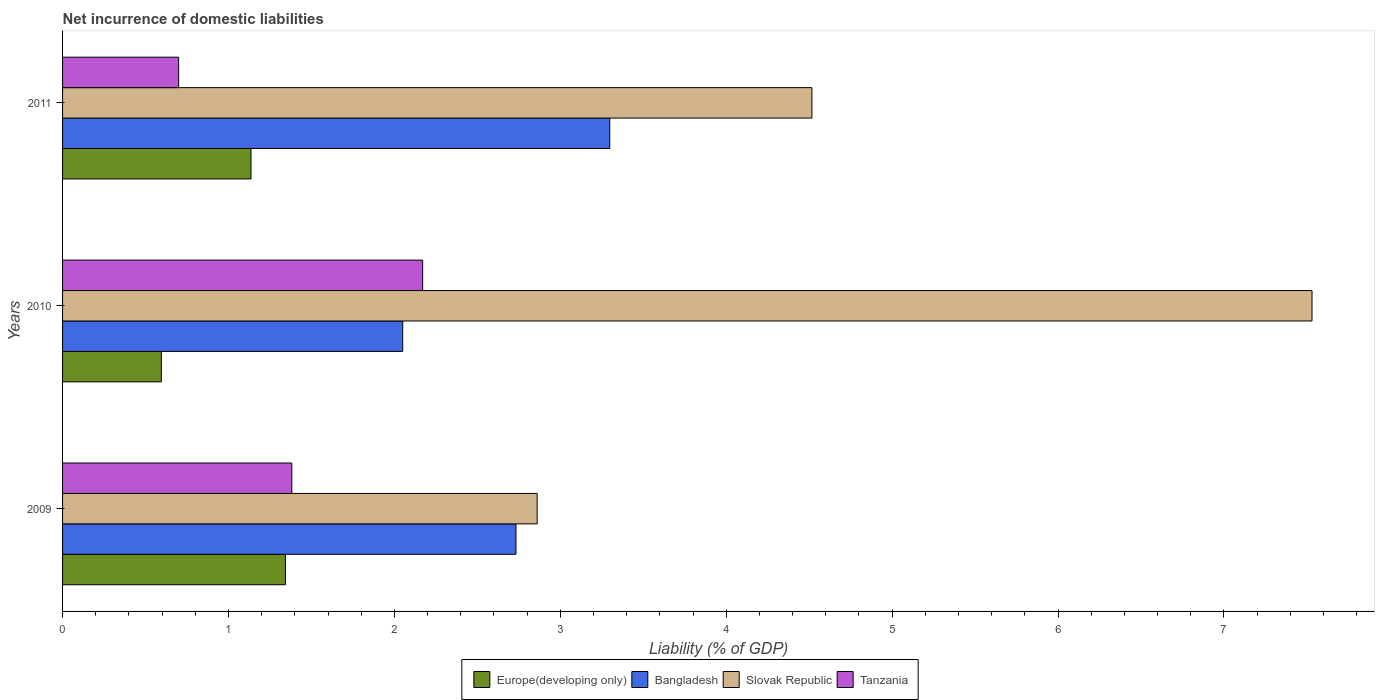Are the number of bars per tick equal to the number of legend labels?
Your answer should be compact. Yes. How many bars are there on the 2nd tick from the top?
Offer a very short reply. 4. In how many cases, is the number of bars for a given year not equal to the number of legend labels?
Offer a terse response. 0. What is the net incurrence of domestic liabilities in Europe(developing only) in 2010?
Provide a short and direct response. 0.6. Across all years, what is the maximum net incurrence of domestic liabilities in Slovak Republic?
Offer a terse response. 7.53. Across all years, what is the minimum net incurrence of domestic liabilities in Bangladesh?
Provide a short and direct response. 2.05. In which year was the net incurrence of domestic liabilities in Tanzania minimum?
Your answer should be compact. 2011. What is the total net incurrence of domestic liabilities in Slovak Republic in the graph?
Give a very brief answer. 14.91. What is the difference between the net incurrence of domestic liabilities in Europe(developing only) in 2009 and that in 2011?
Offer a terse response. 0.21. What is the difference between the net incurrence of domestic liabilities in Bangladesh in 2010 and the net incurrence of domestic liabilities in Tanzania in 2009?
Offer a very short reply. 0.67. What is the average net incurrence of domestic liabilities in Slovak Republic per year?
Make the answer very short. 4.97. In the year 2009, what is the difference between the net incurrence of domestic liabilities in Tanzania and net incurrence of domestic liabilities in Europe(developing only)?
Ensure brevity in your answer.  0.04. In how many years, is the net incurrence of domestic liabilities in Slovak Republic greater than 5.6 %?
Your answer should be very brief. 1. What is the ratio of the net incurrence of domestic liabilities in Europe(developing only) in 2010 to that in 2011?
Provide a succinct answer. 0.52. Is the net incurrence of domestic liabilities in Slovak Republic in 2009 less than that in 2011?
Ensure brevity in your answer.  Yes. Is the difference between the net incurrence of domestic liabilities in Tanzania in 2009 and 2011 greater than the difference between the net incurrence of domestic liabilities in Europe(developing only) in 2009 and 2011?
Ensure brevity in your answer.  Yes. What is the difference between the highest and the second highest net incurrence of domestic liabilities in Slovak Republic?
Ensure brevity in your answer.  3.01. What is the difference between the highest and the lowest net incurrence of domestic liabilities in Europe(developing only)?
Provide a succinct answer. 0.75. Is the sum of the net incurrence of domestic liabilities in Europe(developing only) in 2009 and 2011 greater than the maximum net incurrence of domestic liabilities in Tanzania across all years?
Keep it short and to the point. Yes. What does the 2nd bar from the top in 2010 represents?
Provide a short and direct response. Slovak Republic. What does the 4th bar from the bottom in 2009 represents?
Your answer should be very brief. Tanzania. Is it the case that in every year, the sum of the net incurrence of domestic liabilities in Tanzania and net incurrence of domestic liabilities in Slovak Republic is greater than the net incurrence of domestic liabilities in Europe(developing only)?
Keep it short and to the point. Yes. How many bars are there?
Ensure brevity in your answer.  12. Are all the bars in the graph horizontal?
Offer a terse response. Yes. How many years are there in the graph?
Offer a very short reply. 3. What is the difference between two consecutive major ticks on the X-axis?
Provide a succinct answer. 1. Are the values on the major ticks of X-axis written in scientific E-notation?
Give a very brief answer. No. Where does the legend appear in the graph?
Keep it short and to the point. Bottom center. How many legend labels are there?
Offer a terse response. 4. How are the legend labels stacked?
Make the answer very short. Horizontal. What is the title of the graph?
Keep it short and to the point. Net incurrence of domestic liabilities. Does "Djibouti" appear as one of the legend labels in the graph?
Your response must be concise. No. What is the label or title of the X-axis?
Your answer should be very brief. Liability (% of GDP). What is the Liability (% of GDP) in Europe(developing only) in 2009?
Offer a very short reply. 1.34. What is the Liability (% of GDP) of Bangladesh in 2009?
Provide a short and direct response. 2.73. What is the Liability (% of GDP) in Slovak Republic in 2009?
Give a very brief answer. 2.86. What is the Liability (% of GDP) of Tanzania in 2009?
Give a very brief answer. 1.38. What is the Liability (% of GDP) of Europe(developing only) in 2010?
Keep it short and to the point. 0.6. What is the Liability (% of GDP) of Bangladesh in 2010?
Provide a short and direct response. 2.05. What is the Liability (% of GDP) in Slovak Republic in 2010?
Give a very brief answer. 7.53. What is the Liability (% of GDP) in Tanzania in 2010?
Provide a succinct answer. 2.17. What is the Liability (% of GDP) of Europe(developing only) in 2011?
Provide a short and direct response. 1.14. What is the Liability (% of GDP) in Bangladesh in 2011?
Provide a short and direct response. 3.3. What is the Liability (% of GDP) in Slovak Republic in 2011?
Provide a succinct answer. 4.52. What is the Liability (% of GDP) in Tanzania in 2011?
Keep it short and to the point. 0.7. Across all years, what is the maximum Liability (% of GDP) of Europe(developing only)?
Offer a terse response. 1.34. Across all years, what is the maximum Liability (% of GDP) of Bangladesh?
Offer a very short reply. 3.3. Across all years, what is the maximum Liability (% of GDP) in Slovak Republic?
Provide a short and direct response. 7.53. Across all years, what is the maximum Liability (% of GDP) in Tanzania?
Your answer should be compact. 2.17. Across all years, what is the minimum Liability (% of GDP) in Europe(developing only)?
Make the answer very short. 0.6. Across all years, what is the minimum Liability (% of GDP) in Bangladesh?
Give a very brief answer. 2.05. Across all years, what is the minimum Liability (% of GDP) of Slovak Republic?
Make the answer very short. 2.86. Across all years, what is the minimum Liability (% of GDP) of Tanzania?
Offer a terse response. 0.7. What is the total Liability (% of GDP) of Europe(developing only) in the graph?
Provide a succinct answer. 3.07. What is the total Liability (% of GDP) in Bangladesh in the graph?
Offer a terse response. 8.08. What is the total Liability (% of GDP) of Slovak Republic in the graph?
Keep it short and to the point. 14.91. What is the total Liability (% of GDP) of Tanzania in the graph?
Make the answer very short. 4.25. What is the difference between the Liability (% of GDP) in Europe(developing only) in 2009 and that in 2010?
Ensure brevity in your answer.  0.75. What is the difference between the Liability (% of GDP) of Bangladesh in 2009 and that in 2010?
Ensure brevity in your answer.  0.68. What is the difference between the Liability (% of GDP) of Slovak Republic in 2009 and that in 2010?
Offer a terse response. -4.67. What is the difference between the Liability (% of GDP) of Tanzania in 2009 and that in 2010?
Provide a short and direct response. -0.79. What is the difference between the Liability (% of GDP) in Europe(developing only) in 2009 and that in 2011?
Ensure brevity in your answer.  0.21. What is the difference between the Liability (% of GDP) of Bangladesh in 2009 and that in 2011?
Provide a short and direct response. -0.57. What is the difference between the Liability (% of GDP) of Slovak Republic in 2009 and that in 2011?
Your answer should be very brief. -1.66. What is the difference between the Liability (% of GDP) in Tanzania in 2009 and that in 2011?
Offer a very short reply. 0.68. What is the difference between the Liability (% of GDP) in Europe(developing only) in 2010 and that in 2011?
Your response must be concise. -0.54. What is the difference between the Liability (% of GDP) in Bangladesh in 2010 and that in 2011?
Keep it short and to the point. -1.25. What is the difference between the Liability (% of GDP) in Slovak Republic in 2010 and that in 2011?
Offer a very short reply. 3.01. What is the difference between the Liability (% of GDP) of Tanzania in 2010 and that in 2011?
Ensure brevity in your answer.  1.47. What is the difference between the Liability (% of GDP) of Europe(developing only) in 2009 and the Liability (% of GDP) of Bangladesh in 2010?
Your answer should be compact. -0.71. What is the difference between the Liability (% of GDP) in Europe(developing only) in 2009 and the Liability (% of GDP) in Slovak Republic in 2010?
Ensure brevity in your answer.  -6.19. What is the difference between the Liability (% of GDP) in Europe(developing only) in 2009 and the Liability (% of GDP) in Tanzania in 2010?
Ensure brevity in your answer.  -0.83. What is the difference between the Liability (% of GDP) of Bangladesh in 2009 and the Liability (% of GDP) of Slovak Republic in 2010?
Provide a short and direct response. -4.8. What is the difference between the Liability (% of GDP) of Bangladesh in 2009 and the Liability (% of GDP) of Tanzania in 2010?
Your response must be concise. 0.56. What is the difference between the Liability (% of GDP) in Slovak Republic in 2009 and the Liability (% of GDP) in Tanzania in 2010?
Make the answer very short. 0.69. What is the difference between the Liability (% of GDP) of Europe(developing only) in 2009 and the Liability (% of GDP) of Bangladesh in 2011?
Your response must be concise. -1.95. What is the difference between the Liability (% of GDP) of Europe(developing only) in 2009 and the Liability (% of GDP) of Slovak Republic in 2011?
Your answer should be very brief. -3.17. What is the difference between the Liability (% of GDP) of Europe(developing only) in 2009 and the Liability (% of GDP) of Tanzania in 2011?
Offer a very short reply. 0.64. What is the difference between the Liability (% of GDP) of Bangladesh in 2009 and the Liability (% of GDP) of Slovak Republic in 2011?
Offer a terse response. -1.78. What is the difference between the Liability (% of GDP) in Bangladesh in 2009 and the Liability (% of GDP) in Tanzania in 2011?
Offer a very short reply. 2.03. What is the difference between the Liability (% of GDP) in Slovak Republic in 2009 and the Liability (% of GDP) in Tanzania in 2011?
Your answer should be very brief. 2.16. What is the difference between the Liability (% of GDP) of Europe(developing only) in 2010 and the Liability (% of GDP) of Bangladesh in 2011?
Your answer should be compact. -2.7. What is the difference between the Liability (% of GDP) in Europe(developing only) in 2010 and the Liability (% of GDP) in Slovak Republic in 2011?
Your answer should be compact. -3.92. What is the difference between the Liability (% of GDP) of Europe(developing only) in 2010 and the Liability (% of GDP) of Tanzania in 2011?
Your answer should be compact. -0.1. What is the difference between the Liability (% of GDP) in Bangladesh in 2010 and the Liability (% of GDP) in Slovak Republic in 2011?
Make the answer very short. -2.47. What is the difference between the Liability (% of GDP) of Bangladesh in 2010 and the Liability (% of GDP) of Tanzania in 2011?
Give a very brief answer. 1.35. What is the difference between the Liability (% of GDP) in Slovak Republic in 2010 and the Liability (% of GDP) in Tanzania in 2011?
Offer a terse response. 6.83. What is the average Liability (% of GDP) in Europe(developing only) per year?
Offer a terse response. 1.02. What is the average Liability (% of GDP) of Bangladesh per year?
Make the answer very short. 2.69. What is the average Liability (% of GDP) in Slovak Republic per year?
Offer a very short reply. 4.97. What is the average Liability (% of GDP) of Tanzania per year?
Ensure brevity in your answer.  1.42. In the year 2009, what is the difference between the Liability (% of GDP) of Europe(developing only) and Liability (% of GDP) of Bangladesh?
Give a very brief answer. -1.39. In the year 2009, what is the difference between the Liability (% of GDP) of Europe(developing only) and Liability (% of GDP) of Slovak Republic?
Keep it short and to the point. -1.52. In the year 2009, what is the difference between the Liability (% of GDP) of Europe(developing only) and Liability (% of GDP) of Tanzania?
Keep it short and to the point. -0.04. In the year 2009, what is the difference between the Liability (% of GDP) in Bangladesh and Liability (% of GDP) in Slovak Republic?
Ensure brevity in your answer.  -0.13. In the year 2009, what is the difference between the Liability (% of GDP) of Bangladesh and Liability (% of GDP) of Tanzania?
Your answer should be compact. 1.35. In the year 2009, what is the difference between the Liability (% of GDP) of Slovak Republic and Liability (% of GDP) of Tanzania?
Provide a short and direct response. 1.48. In the year 2010, what is the difference between the Liability (% of GDP) in Europe(developing only) and Liability (% of GDP) in Bangladesh?
Keep it short and to the point. -1.45. In the year 2010, what is the difference between the Liability (% of GDP) in Europe(developing only) and Liability (% of GDP) in Slovak Republic?
Offer a terse response. -6.94. In the year 2010, what is the difference between the Liability (% of GDP) of Europe(developing only) and Liability (% of GDP) of Tanzania?
Provide a short and direct response. -1.57. In the year 2010, what is the difference between the Liability (% of GDP) in Bangladesh and Liability (% of GDP) in Slovak Republic?
Your answer should be compact. -5.48. In the year 2010, what is the difference between the Liability (% of GDP) in Bangladesh and Liability (% of GDP) in Tanzania?
Ensure brevity in your answer.  -0.12. In the year 2010, what is the difference between the Liability (% of GDP) of Slovak Republic and Liability (% of GDP) of Tanzania?
Your answer should be very brief. 5.36. In the year 2011, what is the difference between the Liability (% of GDP) of Europe(developing only) and Liability (% of GDP) of Bangladesh?
Give a very brief answer. -2.16. In the year 2011, what is the difference between the Liability (% of GDP) of Europe(developing only) and Liability (% of GDP) of Slovak Republic?
Provide a succinct answer. -3.38. In the year 2011, what is the difference between the Liability (% of GDP) of Europe(developing only) and Liability (% of GDP) of Tanzania?
Offer a terse response. 0.44. In the year 2011, what is the difference between the Liability (% of GDP) of Bangladesh and Liability (% of GDP) of Slovak Republic?
Offer a terse response. -1.22. In the year 2011, what is the difference between the Liability (% of GDP) of Bangladesh and Liability (% of GDP) of Tanzania?
Offer a very short reply. 2.6. In the year 2011, what is the difference between the Liability (% of GDP) of Slovak Republic and Liability (% of GDP) of Tanzania?
Keep it short and to the point. 3.82. What is the ratio of the Liability (% of GDP) of Europe(developing only) in 2009 to that in 2010?
Make the answer very short. 2.26. What is the ratio of the Liability (% of GDP) of Bangladesh in 2009 to that in 2010?
Make the answer very short. 1.33. What is the ratio of the Liability (% of GDP) of Slovak Republic in 2009 to that in 2010?
Make the answer very short. 0.38. What is the ratio of the Liability (% of GDP) of Tanzania in 2009 to that in 2010?
Give a very brief answer. 0.64. What is the ratio of the Liability (% of GDP) of Europe(developing only) in 2009 to that in 2011?
Give a very brief answer. 1.18. What is the ratio of the Liability (% of GDP) of Bangladesh in 2009 to that in 2011?
Provide a succinct answer. 0.83. What is the ratio of the Liability (% of GDP) of Slovak Republic in 2009 to that in 2011?
Make the answer very short. 0.63. What is the ratio of the Liability (% of GDP) of Tanzania in 2009 to that in 2011?
Your answer should be compact. 1.98. What is the ratio of the Liability (% of GDP) in Europe(developing only) in 2010 to that in 2011?
Offer a very short reply. 0.52. What is the ratio of the Liability (% of GDP) of Bangladesh in 2010 to that in 2011?
Make the answer very short. 0.62. What is the ratio of the Liability (% of GDP) in Slovak Republic in 2010 to that in 2011?
Keep it short and to the point. 1.67. What is the ratio of the Liability (% of GDP) in Tanzania in 2010 to that in 2011?
Your answer should be compact. 3.1. What is the difference between the highest and the second highest Liability (% of GDP) in Europe(developing only)?
Make the answer very short. 0.21. What is the difference between the highest and the second highest Liability (% of GDP) of Bangladesh?
Give a very brief answer. 0.57. What is the difference between the highest and the second highest Liability (% of GDP) in Slovak Republic?
Keep it short and to the point. 3.01. What is the difference between the highest and the second highest Liability (% of GDP) in Tanzania?
Offer a terse response. 0.79. What is the difference between the highest and the lowest Liability (% of GDP) in Europe(developing only)?
Give a very brief answer. 0.75. What is the difference between the highest and the lowest Liability (% of GDP) in Bangladesh?
Your answer should be compact. 1.25. What is the difference between the highest and the lowest Liability (% of GDP) in Slovak Republic?
Provide a short and direct response. 4.67. What is the difference between the highest and the lowest Liability (% of GDP) in Tanzania?
Provide a succinct answer. 1.47. 